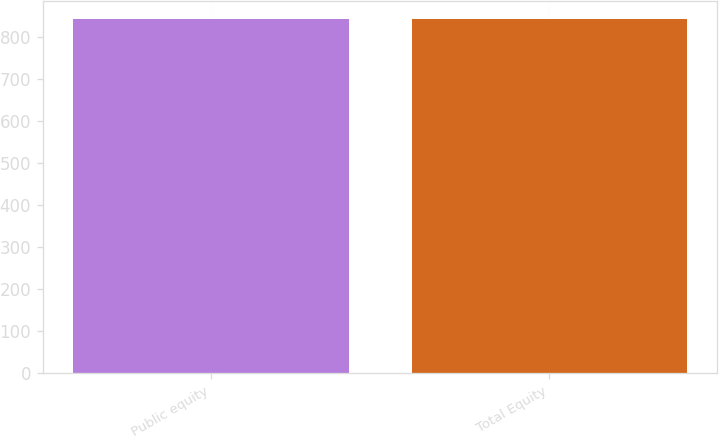<chart> <loc_0><loc_0><loc_500><loc_500><bar_chart><fcel>Public equity<fcel>Total Equity<nl><fcel>843<fcel>844<nl></chart> 